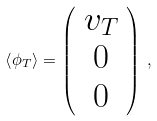Convert formula to latex. <formula><loc_0><loc_0><loc_500><loc_500>\left < \phi _ { T } \right > = \left ( \begin{array} { c } v _ { T } \\ 0 \\ 0 \end{array} \right ) \, ,</formula> 